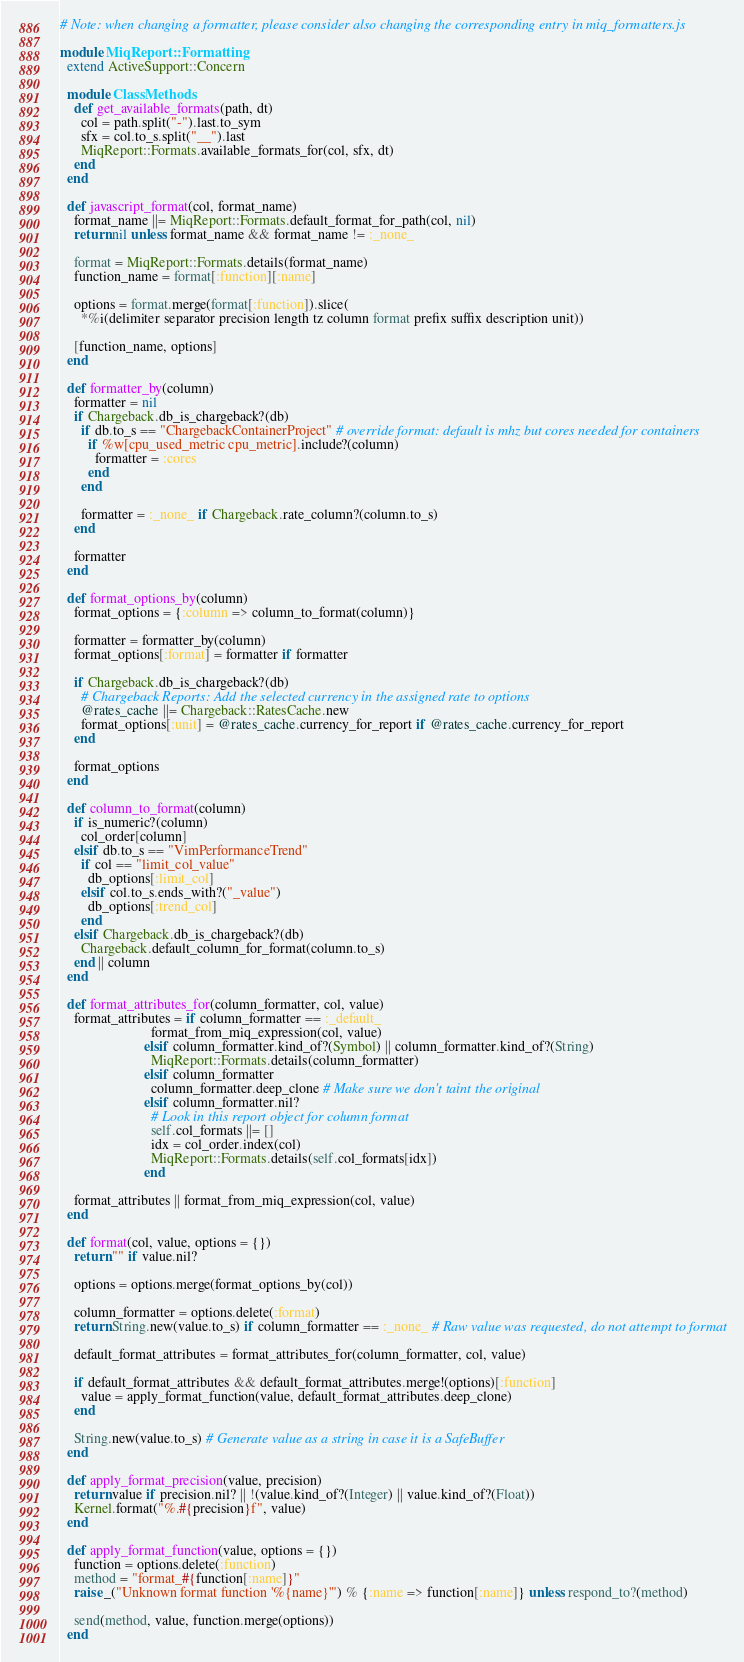Convert code to text. <code><loc_0><loc_0><loc_500><loc_500><_Ruby_># Note: when changing a formatter, please consider also changing the corresponding entry in miq_formatters.js

module MiqReport::Formatting
  extend ActiveSupport::Concern

  module ClassMethods
    def get_available_formats(path, dt)
      col = path.split("-").last.to_sym
      sfx = col.to_s.split("__").last
      MiqReport::Formats.available_formats_for(col, sfx, dt)
    end
  end

  def javascript_format(col, format_name)
    format_name ||= MiqReport::Formats.default_format_for_path(col, nil)
    return nil unless format_name && format_name != :_none_

    format = MiqReport::Formats.details(format_name)
    function_name = format[:function][:name]

    options = format.merge(format[:function]).slice(
      *%i(delimiter separator precision length tz column format prefix suffix description unit))

    [function_name, options]
  end

  def formatter_by(column)
    formatter = nil
    if Chargeback.db_is_chargeback?(db)
      if db.to_s == "ChargebackContainerProject" # override format: default is mhz but cores needed for containers
        if %w[cpu_used_metric cpu_metric].include?(column)
          formatter = :cores
        end
      end

      formatter = :_none_ if Chargeback.rate_column?(column.to_s)
    end

    formatter
  end

  def format_options_by(column)
    format_options = {:column => column_to_format(column)}

    formatter = formatter_by(column)
    format_options[:format] = formatter if formatter

    if Chargeback.db_is_chargeback?(db)
      # Chargeback Reports: Add the selected currency in the assigned rate to options
      @rates_cache ||= Chargeback::RatesCache.new
      format_options[:unit] = @rates_cache.currency_for_report if @rates_cache.currency_for_report
    end

    format_options
  end

  def column_to_format(column)
    if is_numeric?(column)
      col_order[column]
    elsif db.to_s == "VimPerformanceTrend"
      if col == "limit_col_value"
        db_options[:limit_col]
      elsif col.to_s.ends_with?("_value")
        db_options[:trend_col]
      end
    elsif Chargeback.db_is_chargeback?(db)
      Chargeback.default_column_for_format(column.to_s)
    end || column
  end

  def format_attributes_for(column_formatter, col, value)
    format_attributes = if column_formatter == :_default_
                          format_from_miq_expression(col, value)
                        elsif column_formatter.kind_of?(Symbol) || column_formatter.kind_of?(String)
                          MiqReport::Formats.details(column_formatter)
                        elsif column_formatter
                          column_formatter.deep_clone # Make sure we don't taint the original
                        elsif column_formatter.nil?
                          # Look in this report object for column format
                          self.col_formats ||= []
                          idx = col_order.index(col)
                          MiqReport::Formats.details(self.col_formats[idx])
                        end

    format_attributes || format_from_miq_expression(col, value)
  end

  def format(col, value, options = {})
    return "" if value.nil?

    options = options.merge(format_options_by(col))

    column_formatter = options.delete(:format)
    return String.new(value.to_s) if column_formatter == :_none_ # Raw value was requested, do not attempt to format

    default_format_attributes = format_attributes_for(column_formatter, col, value)

    if default_format_attributes && default_format_attributes.merge!(options)[:function]
      value = apply_format_function(value, default_format_attributes.deep_clone)
    end

    String.new(value.to_s) # Generate value as a string in case it is a SafeBuffer
  end

  def apply_format_precision(value, precision)
    return value if precision.nil? || !(value.kind_of?(Integer) || value.kind_of?(Float))
    Kernel.format("%.#{precision}f", value)
  end

  def apply_format_function(value, options = {})
    function = options.delete(:function)
    method = "format_#{function[:name]}"
    raise _("Unknown format function '%{name}'") % {:name => function[:name]} unless respond_to?(method)

    send(method, value, function.merge(options))
  end
</code> 